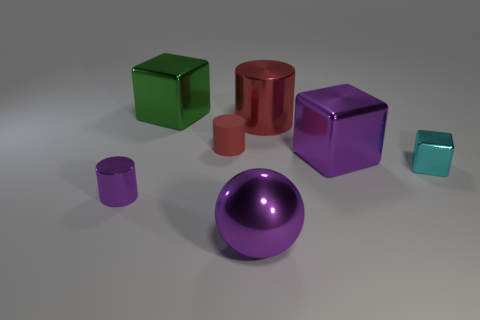Is the small shiny block the same color as the ball? No, the small shiny block is a light teal color, while the ball is a deep purple. Despite the glossy finish that they both share, which could affect the perception of color under different lighting conditions, their colors are quite distinct. 